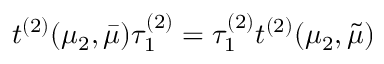<formula> <loc_0><loc_0><loc_500><loc_500>t ^ { ( 2 ) } ( \mu _ { 2 } , \bar { \mu } ) \tau _ { 1 } ^ { ( 2 ) } = \tau _ { 1 } ^ { ( 2 ) } t ^ { ( 2 ) } ( \mu _ { 2 } , \tilde { \mu } )</formula> 